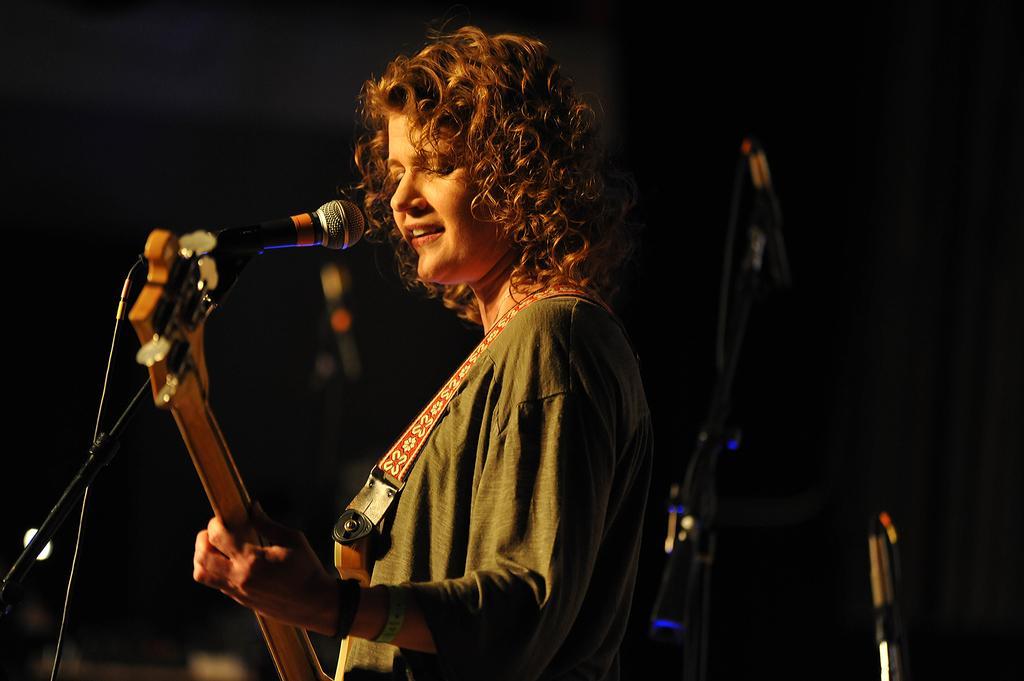How would you summarize this image in a sentence or two? This woman is playing guitar and singing in-front of mic. 